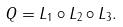<formula> <loc_0><loc_0><loc_500><loc_500>Q = L _ { 1 } \circ L _ { 2 } \circ L _ { 3 } .</formula> 